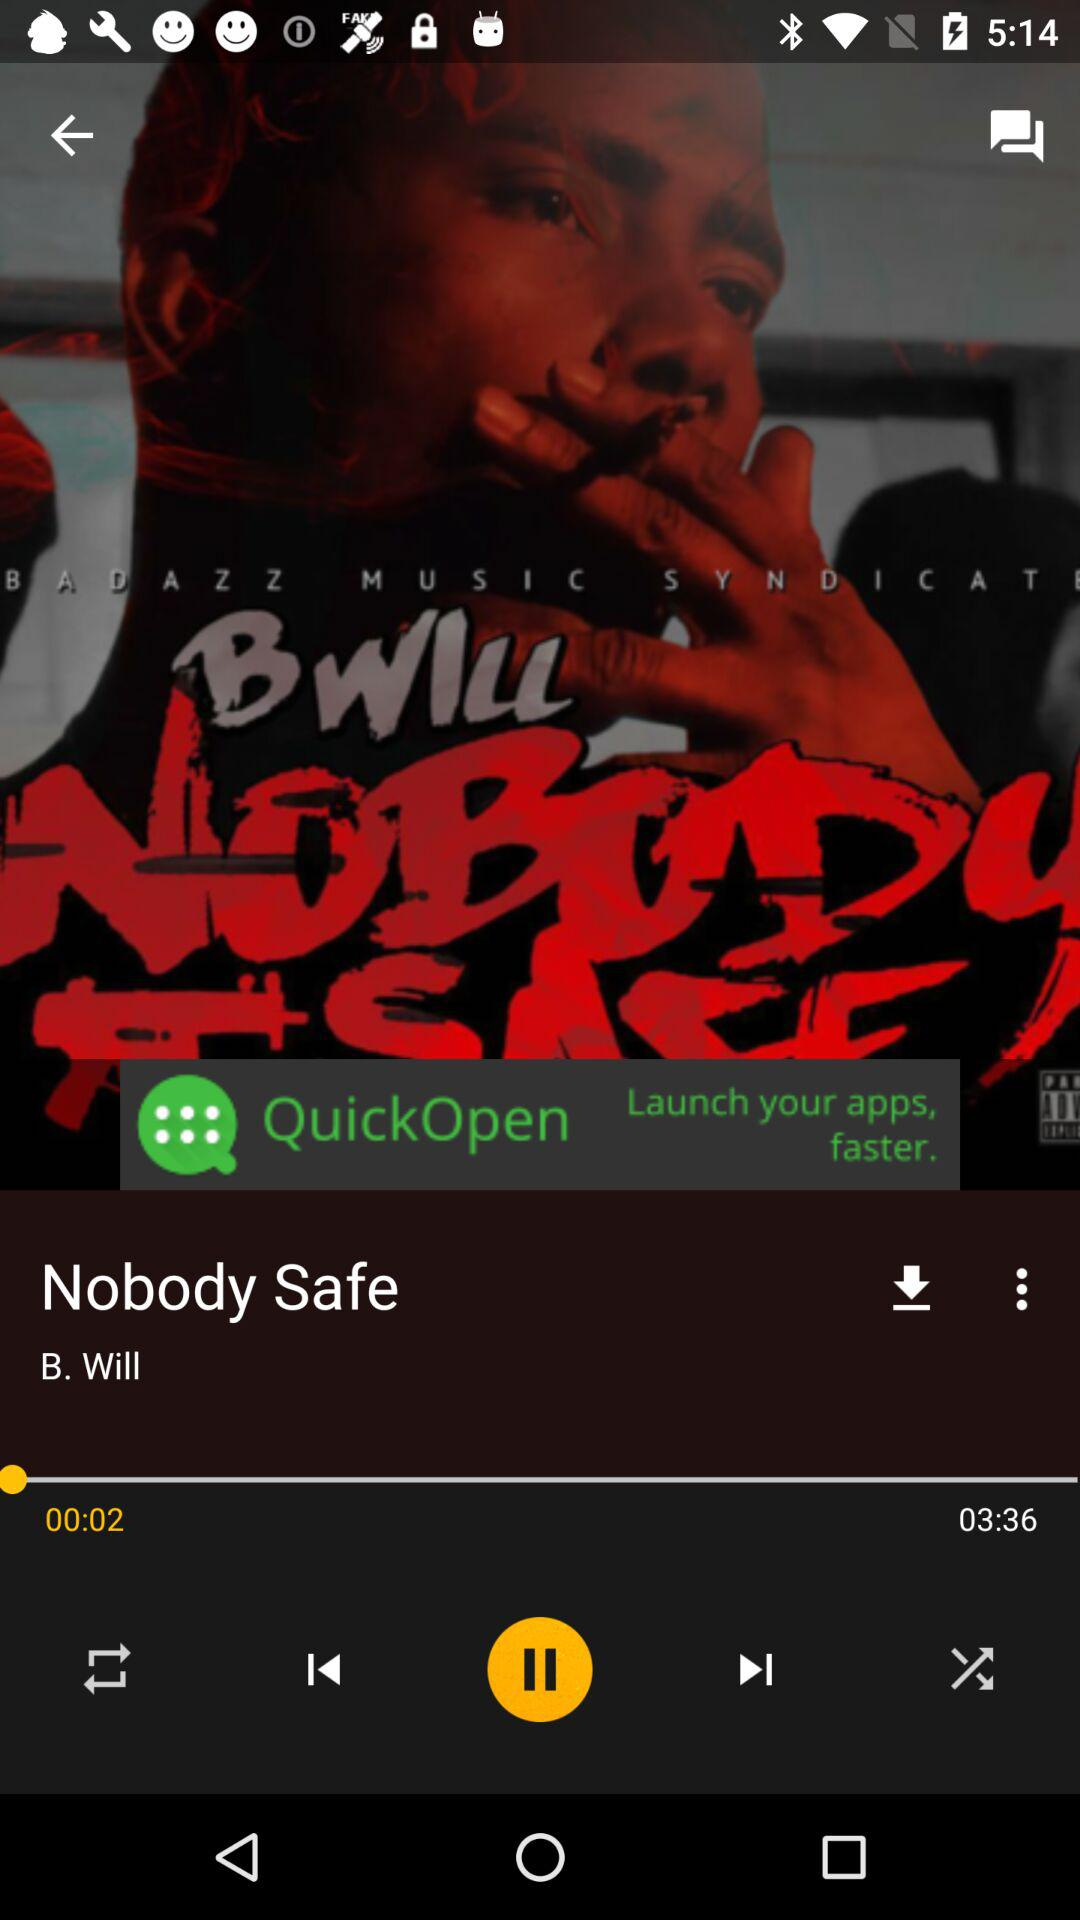Who is the singer of this song?
When the provided information is insufficient, respond with <no answer>. <no answer> 